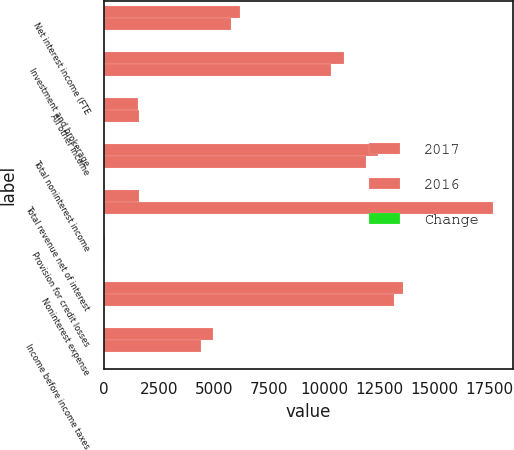Convert chart to OTSL. <chart><loc_0><loc_0><loc_500><loc_500><stacked_bar_chart><ecel><fcel>Net interest income (FTE<fcel>Investment and brokerage<fcel>All other income<fcel>Total noninterest income<fcel>Total revenue net of interest<fcel>Provision for credit losses<fcel>Noninterest expense<fcel>Income before income taxes<nl><fcel>2017<fcel>6173<fcel>10883<fcel>1534<fcel>12417<fcel>1575<fcel>56<fcel>13564<fcel>4970<nl><fcel>2016<fcel>5759<fcel>10316<fcel>1575<fcel>11891<fcel>17650<fcel>68<fcel>13175<fcel>4407<nl><fcel>Change<fcel>7<fcel>5<fcel>3<fcel>4<fcel>5<fcel>18<fcel>3<fcel>13<nl></chart> 